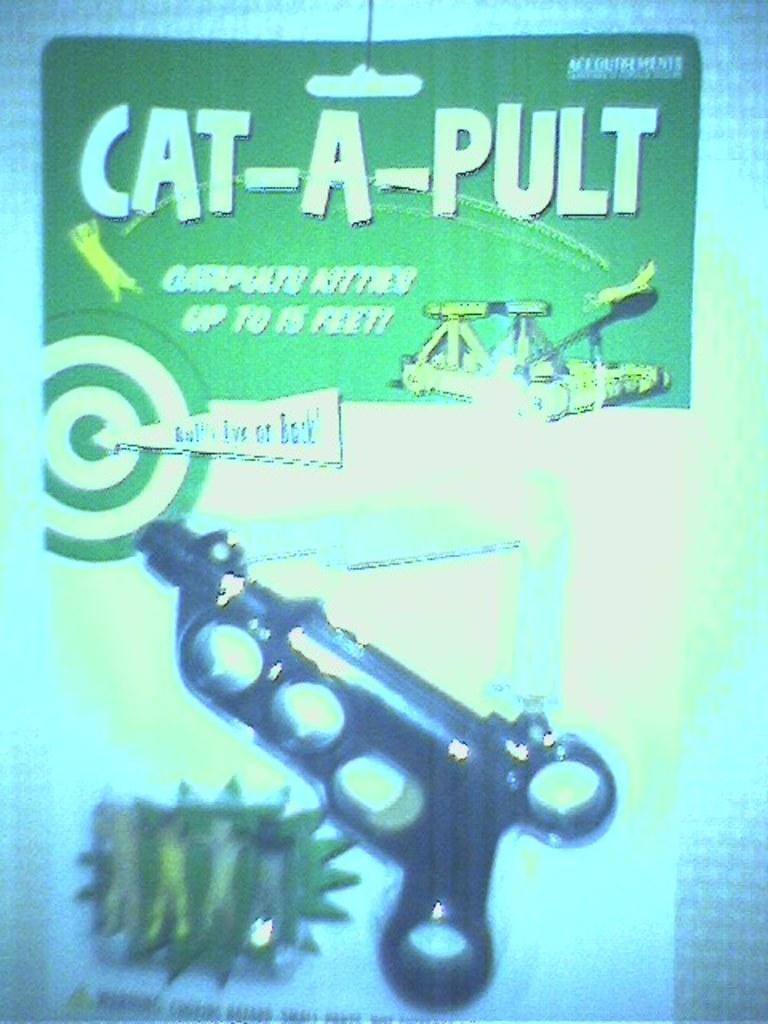<image>
Share a concise interpretation of the image provided. A Cat-A-Pult toy is displayed in green package with a red and white target on it 